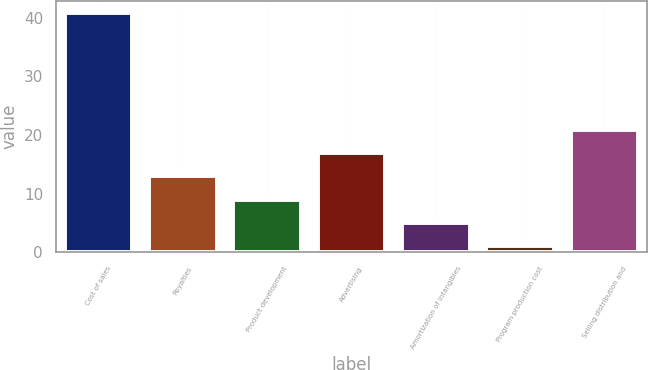Convert chart to OTSL. <chart><loc_0><loc_0><loc_500><loc_500><bar_chart><fcel>Cost of sales<fcel>Royalties<fcel>Product development<fcel>Advertising<fcel>Amortization of intangibles<fcel>Program production cost<fcel>Selling distribution and<nl><fcel>40.9<fcel>12.97<fcel>8.98<fcel>16.96<fcel>4.99<fcel>1<fcel>20.95<nl></chart> 